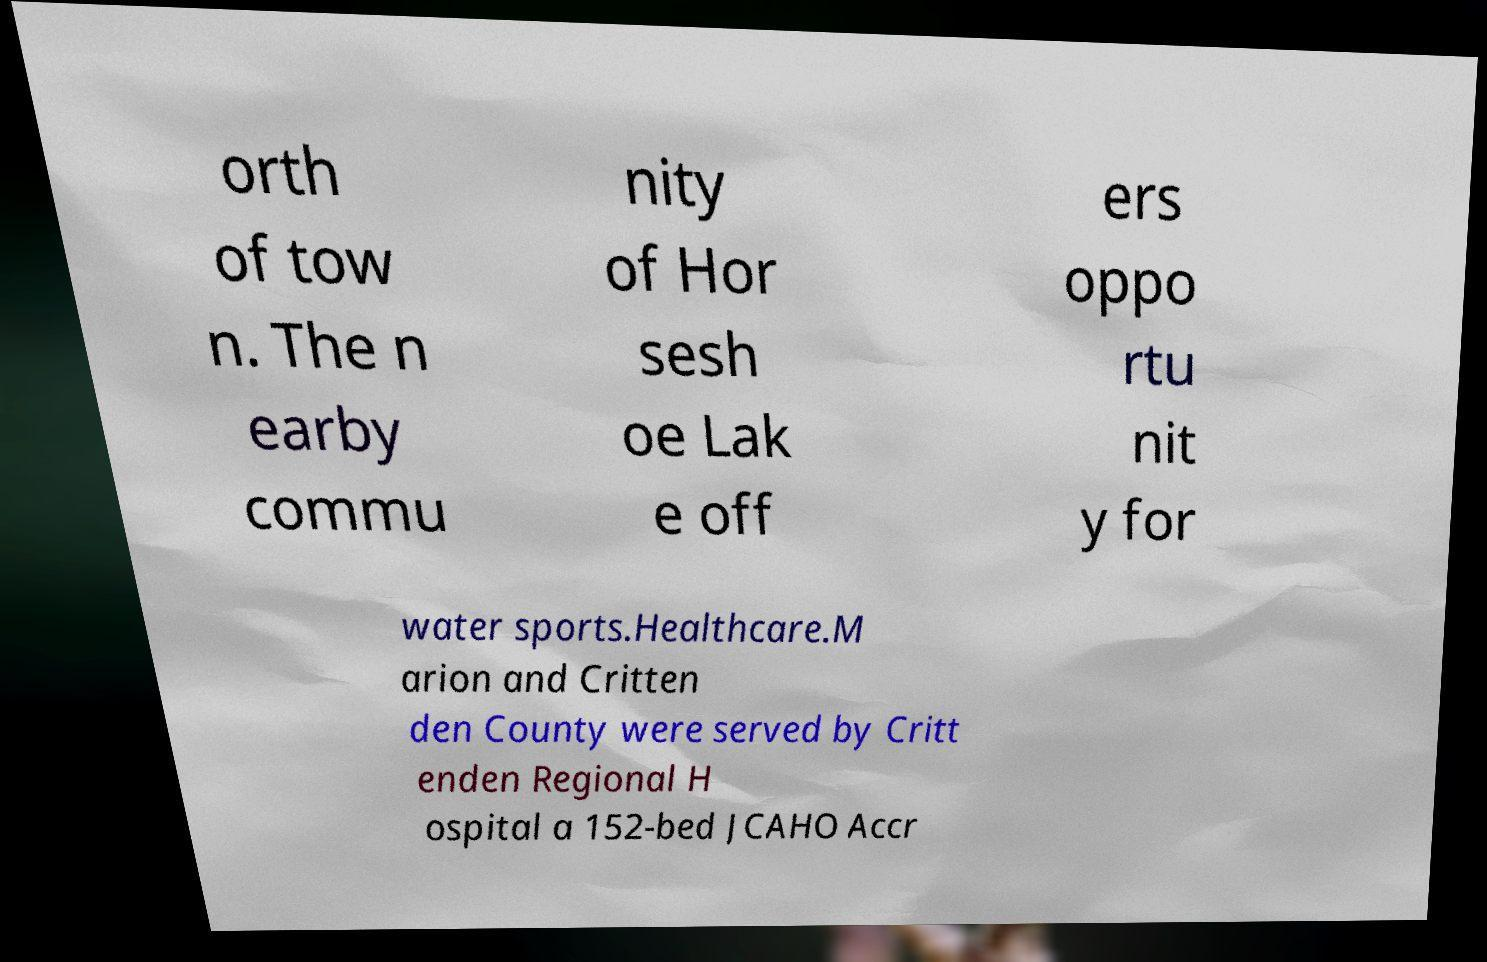What messages or text are displayed in this image? I need them in a readable, typed format. orth of tow n. The n earby commu nity of Hor sesh oe Lak e off ers oppo rtu nit y for water sports.Healthcare.M arion and Critten den County were served by Critt enden Regional H ospital a 152-bed JCAHO Accr 